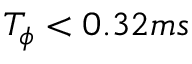<formula> <loc_0><loc_0><loc_500><loc_500>T _ { \phi } < 0 . 3 2 m s</formula> 